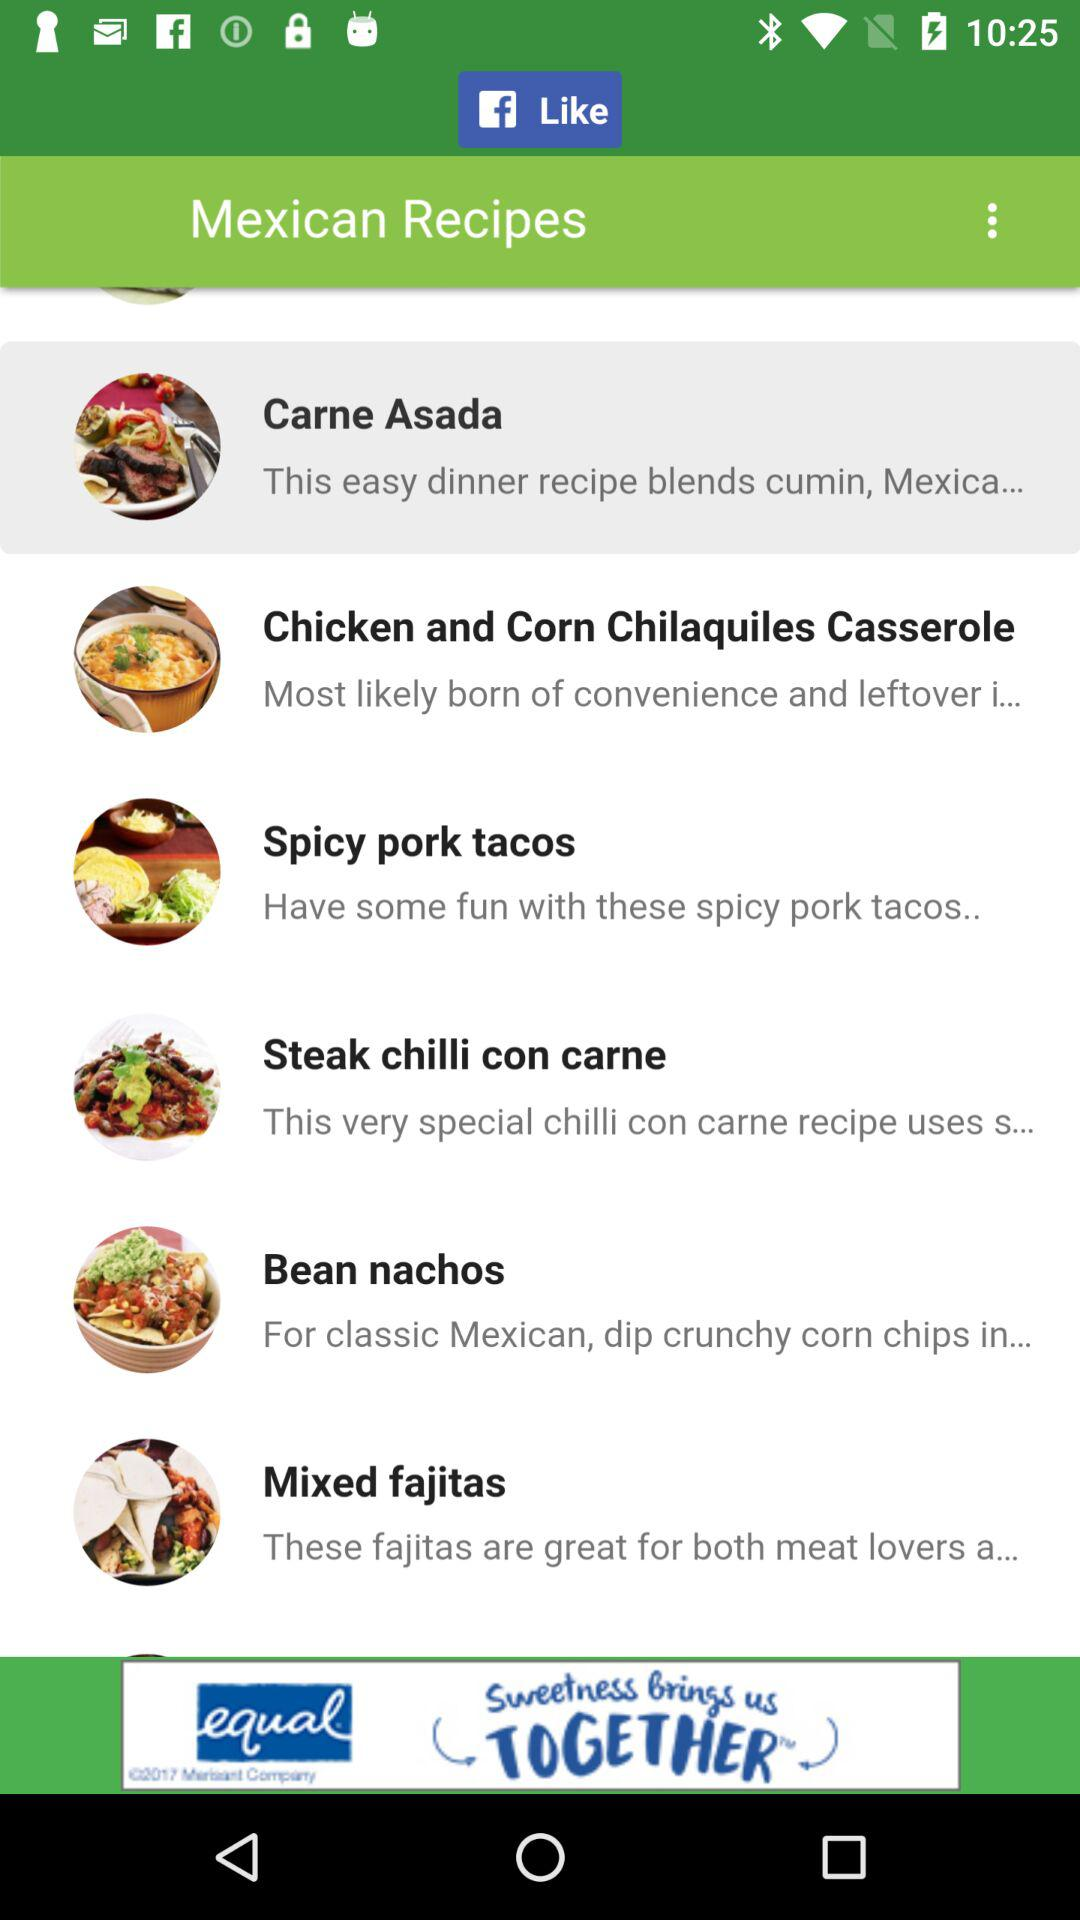Through what application user can like the recipes? The user can like the recipes through "Facebook". 